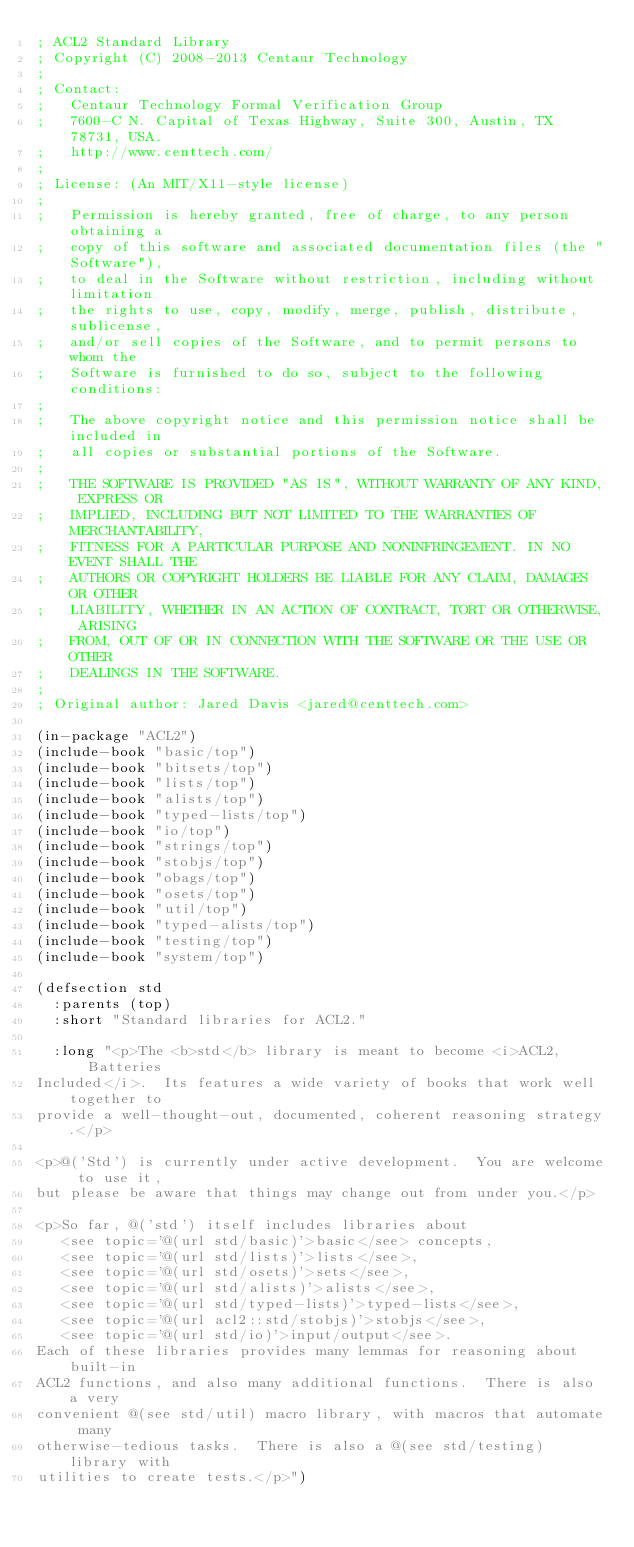Convert code to text. <code><loc_0><loc_0><loc_500><loc_500><_Lisp_>; ACL2 Standard Library
; Copyright (C) 2008-2013 Centaur Technology
;
; Contact:
;   Centaur Technology Formal Verification Group
;   7600-C N. Capital of Texas Highway, Suite 300, Austin, TX 78731, USA.
;   http://www.centtech.com/
;
; License: (An MIT/X11-style license)
;
;   Permission is hereby granted, free of charge, to any person obtaining a
;   copy of this software and associated documentation files (the "Software"),
;   to deal in the Software without restriction, including without limitation
;   the rights to use, copy, modify, merge, publish, distribute, sublicense,
;   and/or sell copies of the Software, and to permit persons to whom the
;   Software is furnished to do so, subject to the following conditions:
;
;   The above copyright notice and this permission notice shall be included in
;   all copies or substantial portions of the Software.
;
;   THE SOFTWARE IS PROVIDED "AS IS", WITHOUT WARRANTY OF ANY KIND, EXPRESS OR
;   IMPLIED, INCLUDING BUT NOT LIMITED TO THE WARRANTIES OF MERCHANTABILITY,
;   FITNESS FOR A PARTICULAR PURPOSE AND NONINFRINGEMENT. IN NO EVENT SHALL THE
;   AUTHORS OR COPYRIGHT HOLDERS BE LIABLE FOR ANY CLAIM, DAMAGES OR OTHER
;   LIABILITY, WHETHER IN AN ACTION OF CONTRACT, TORT OR OTHERWISE, ARISING
;   FROM, OUT OF OR IN CONNECTION WITH THE SOFTWARE OR THE USE OR OTHER
;   DEALINGS IN THE SOFTWARE.
;
; Original author: Jared Davis <jared@centtech.com>

(in-package "ACL2")
(include-book "basic/top")
(include-book "bitsets/top")
(include-book "lists/top")
(include-book "alists/top")
(include-book "typed-lists/top")
(include-book "io/top")
(include-book "strings/top")
(include-book "stobjs/top")
(include-book "obags/top")
(include-book "osets/top")
(include-book "util/top")
(include-book "typed-alists/top")
(include-book "testing/top")
(include-book "system/top")

(defsection std
  :parents (top)
  :short "Standard libraries for ACL2."

  :long "<p>The <b>std</b> library is meant to become <i>ACL2, Batteries
Included</i>.  Its features a wide variety of books that work well together to
provide a well-thought-out, documented, coherent reasoning strategy.</p>

<p>@('Std') is currently under active development.  You are welcome to use it,
but please be aware that things may change out from under you.</p>

<p>So far, @('std') itself includes libraries about
   <see topic='@(url std/basic)'>basic</see> concepts,
   <see topic='@(url std/lists)'>lists</see>,
   <see topic='@(url std/osets)'>sets</see>,
   <see topic='@(url std/alists)'>alists</see>,
   <see topic='@(url std/typed-lists)'>typed-lists</see>,
   <see topic='@(url acl2::std/stobjs)'>stobjs</see>,
   <see topic='@(url std/io)'>input/output</see>.
Each of these libraries provides many lemmas for reasoning about built-in
ACL2 functions, and also many additional functions.  There is also a very
convenient @(see std/util) macro library, with macros that automate many
otherwise-tedious tasks.  There is also a @(see std/testing) library with
utilities to create tests.</p>")
</code> 